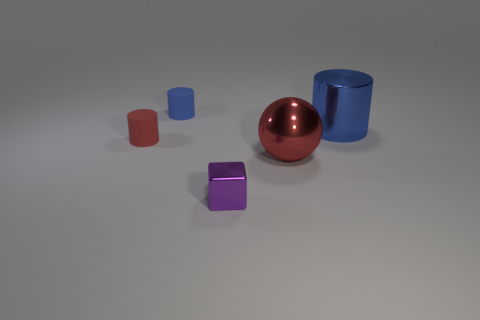There is a cylinder that is both in front of the blue matte cylinder and to the left of the red ball; what is its color?
Keep it short and to the point. Red. Does the blue cylinder left of the purple shiny block have the same size as the shiny thing that is in front of the big red metallic sphere?
Offer a terse response. Yes. How many matte cylinders have the same color as the shiny sphere?
Make the answer very short. 1. How many large objects are either red metallic things or shiny cylinders?
Your answer should be very brief. 2. Are the large thing that is in front of the red matte thing and the tiny blue object made of the same material?
Your answer should be very brief. No. The metal cylinder that is behind the small cube is what color?
Your answer should be compact. Blue. Is there a red thing of the same size as the shiny cube?
Offer a very short reply. Yes. What is the material of the blue object that is the same size as the purple shiny object?
Your answer should be very brief. Rubber. Does the block have the same size as the blue cylinder left of the large red sphere?
Your answer should be very brief. Yes. What is the material of the blue cylinder that is left of the tiny metal thing?
Keep it short and to the point. Rubber. 